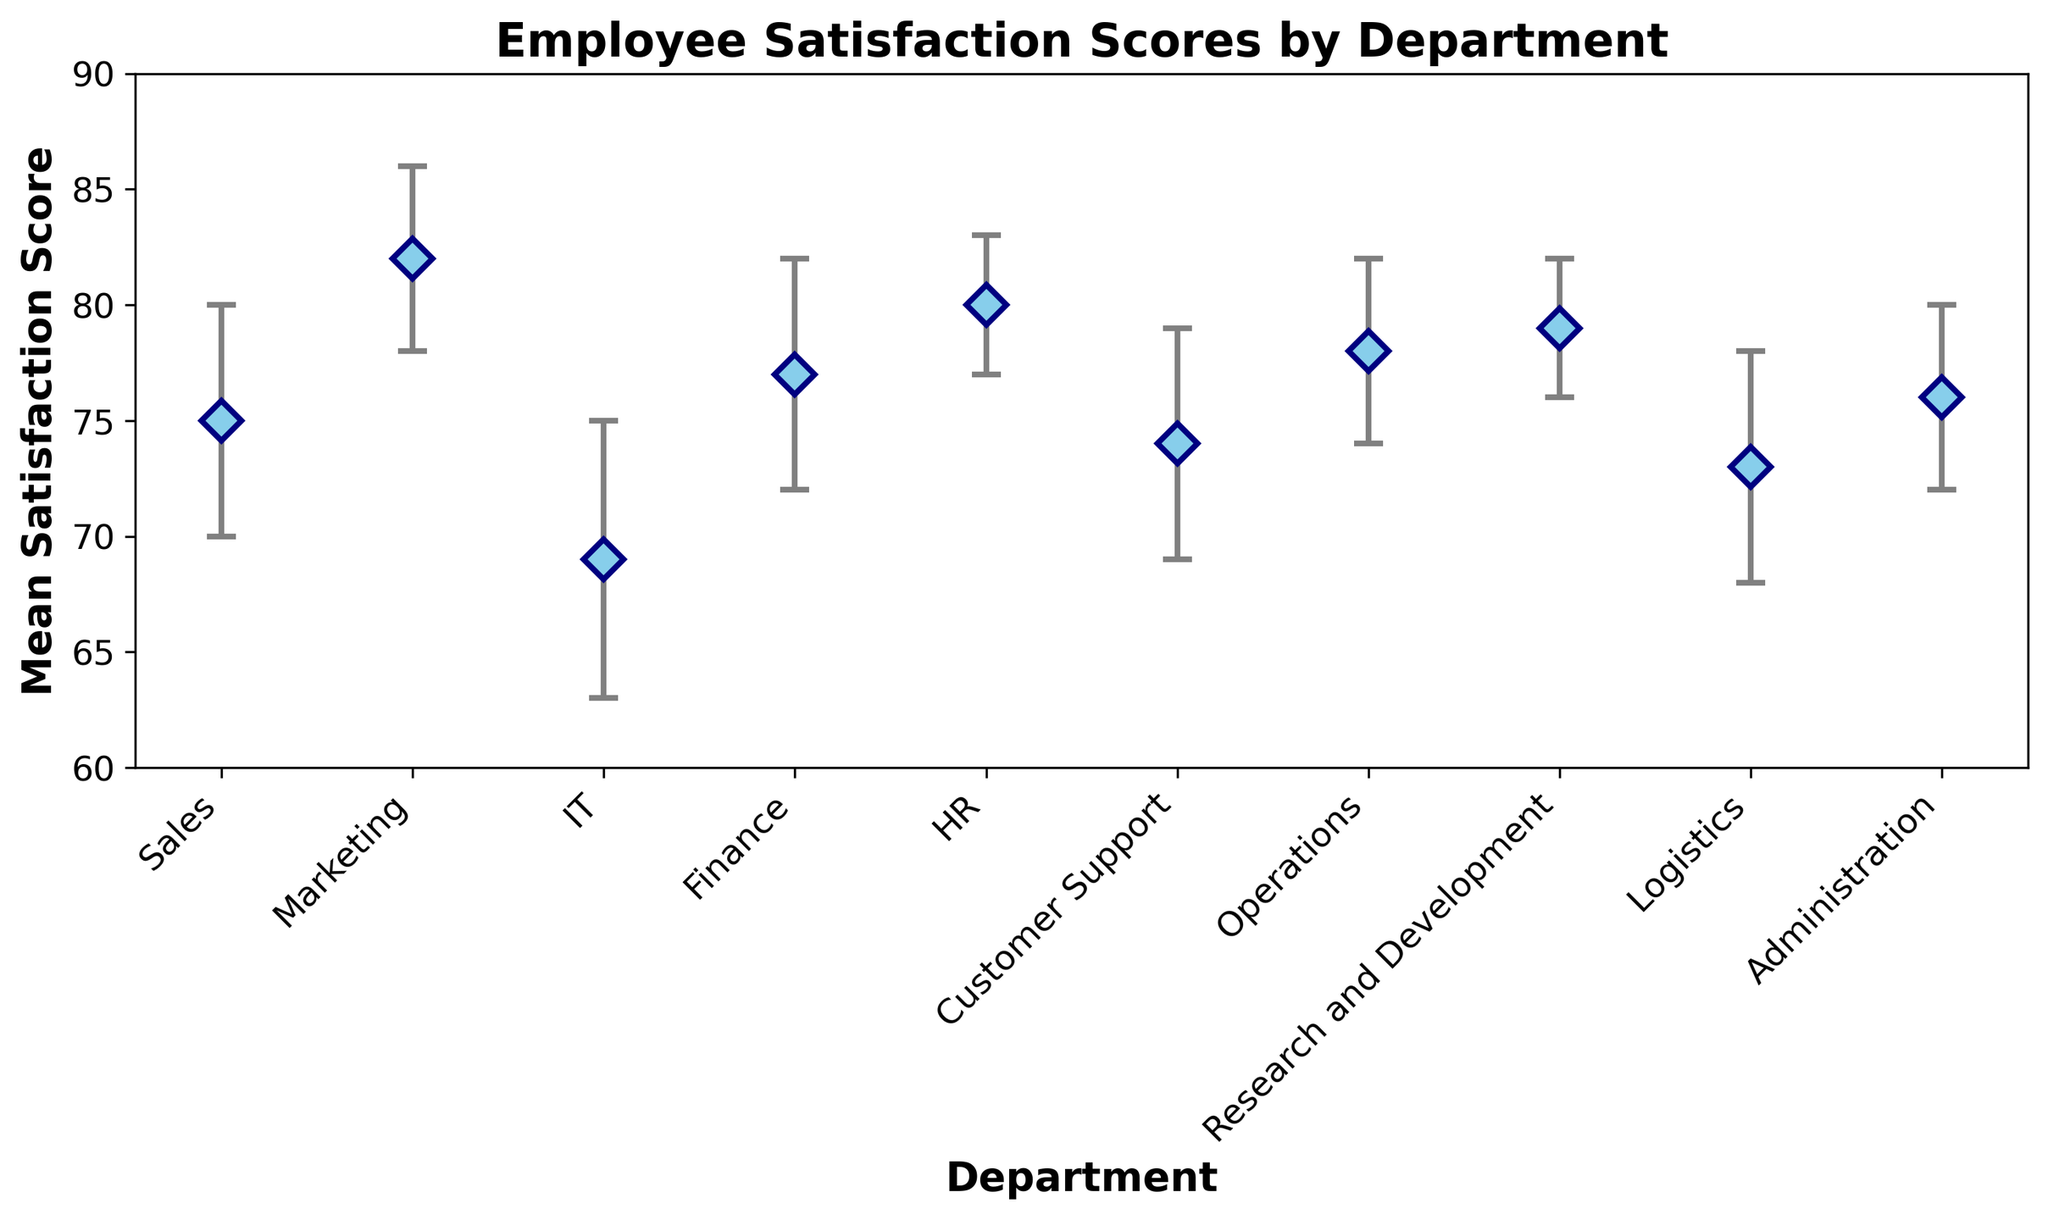Which department has the highest mean employee satisfaction score? By looking at the figure, we identify the department with the highest point on the vertical axis. Marketing has the highest point corresponding to a mean satisfaction score.
Answer: Marketing Which two departments have the lowest mean employee satisfaction scores, and what are the scores? By observing the lower end of the vertical axis, we see that IT and Logistics departments have the lowest points. IT has a score of 69, and Logistics has a score of 73.
Answer: IT (69), Logistics (73) Is the satisfaction score of Finance higher or lower than Administration? By comparing the vertical positions of Finance and Administration, we see that Finance has a mean score of 77 while Administration has 76. Therefore, Finance is slightly higher than Administration.
Answer: Higher What is the difference in mean satisfaction scores between the highest-scoring department and the lowest-scoring department? The highest mean score is in Marketing (82) and the lowest in IT (69). The difference is calculated as 82 - 69.
Answer: 13 Which departments have a mean satisfaction score above 75? By observing the departments whose points are above the 75 mark on the vertical axis, we find Marketing (82), Finance (77), HR (80), Operations (78), and Research and Development (79).
Answer: Marketing, Finance, HR, Operations, Research and Development What is the overall range of mean satisfaction scores across all departments? The range is calculated by subtracting the lowest mean satisfaction score (IT, 69) from the highest mean satisfaction score (Marketing, 82).
Answer: 13 How many departments have an error margin of 5? Looking at the figure, we count the number of points with error bars of length 5. These departments are Sales, Finance, Customer Support, and Logistics.
Answer: 4 Which department has the smallest error margin, and what is the value? By identifying the shortest error bars in the figure, we see that HR and Research and Development have the smallest error margins of 3.
Answer: HR, Research and Development (3) Compare the mean satisfaction score of Customer Support to Operations. By how much does it differ? Customer Support has a score of 74, and Operations has 78. The difference is calculated as 78 - 74.
Answer: 4 What is the mean satisfaction score of the departments in the Operations segment? The mean satisfaction score for Operations is directly indicated on the chart. It is 78.
Answer: 78 